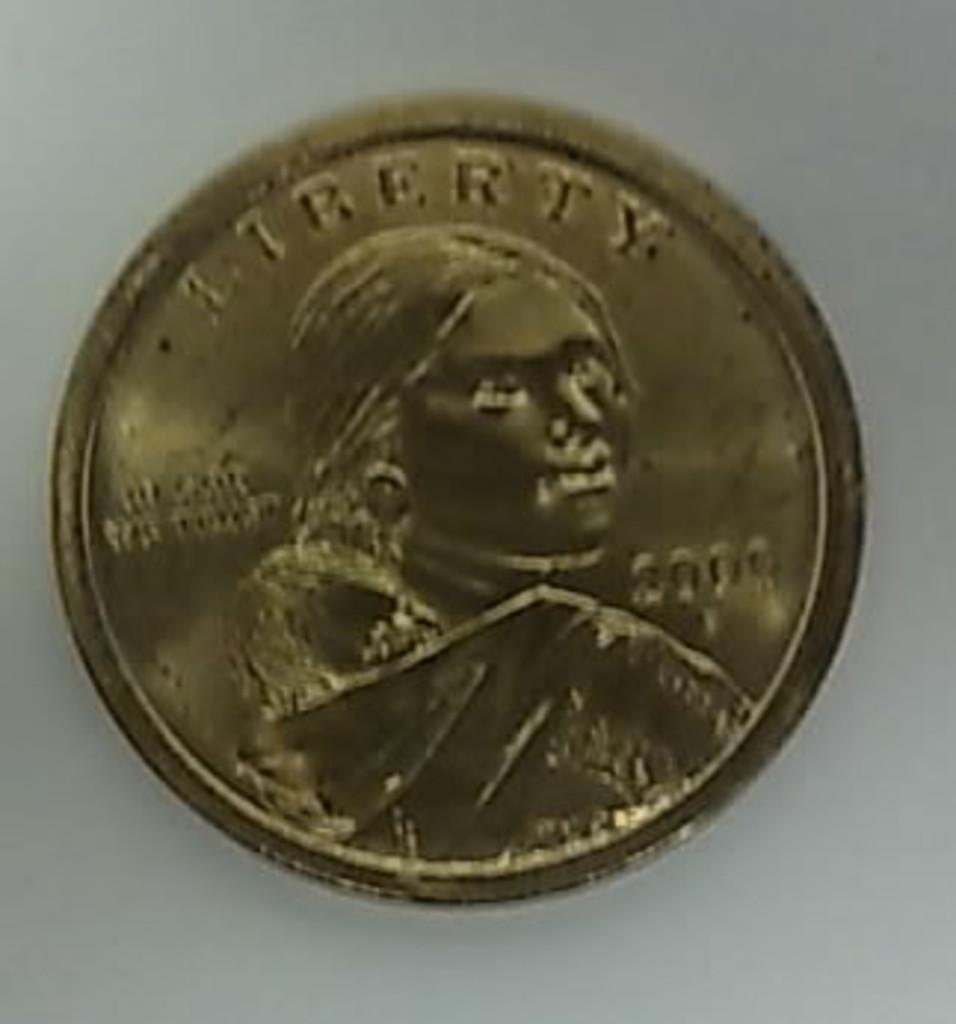<image>
Create a compact narrative representing the image presented. "LIBERTY" is on the top of the round gold coin. 